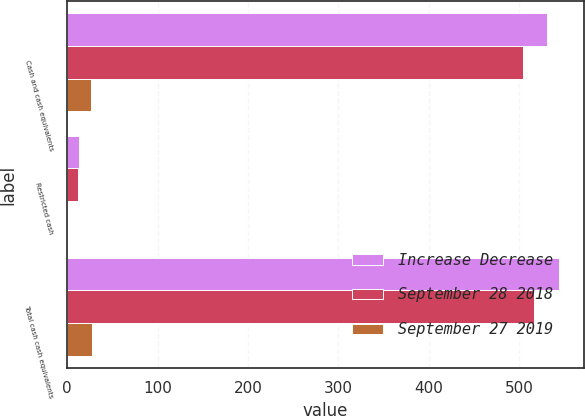<chart> <loc_0><loc_0><loc_500><loc_500><stacked_bar_chart><ecel><fcel>Cash and cash equivalents<fcel>Restricted cash<fcel>Total cash cash equivalents<nl><fcel>Increase Decrease<fcel>531.4<fcel>12.7<fcel>544.1<nl><fcel>September 28 2018<fcel>504.8<fcel>11.6<fcel>516.4<nl><fcel>September 27 2019<fcel>26.6<fcel>1.1<fcel>27.7<nl></chart> 